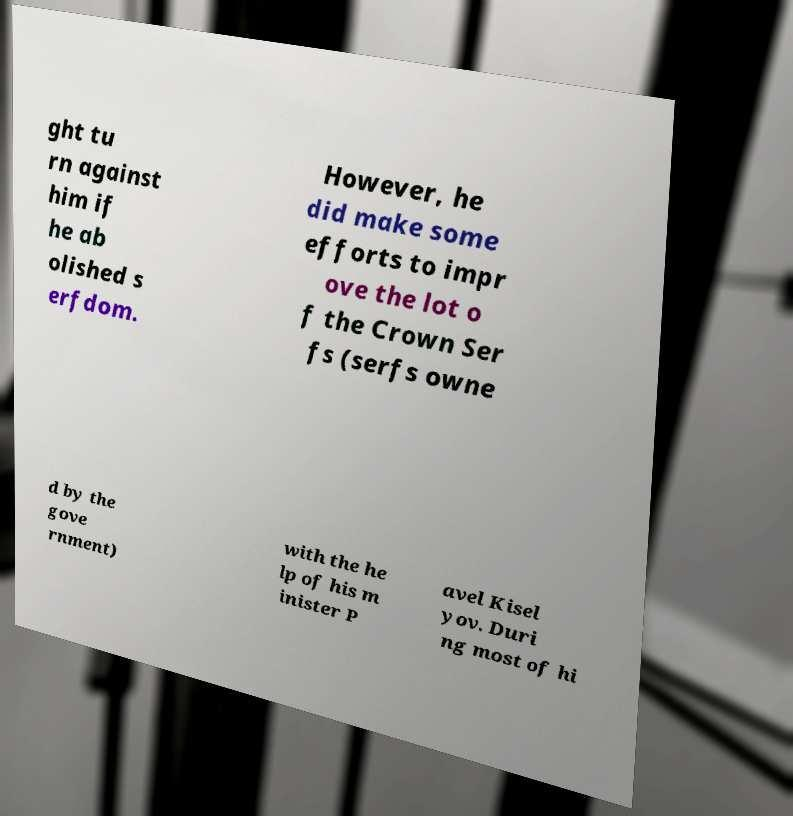Please read and relay the text visible in this image. What does it say? ght tu rn against him if he ab olished s erfdom. However, he did make some efforts to impr ove the lot o f the Crown Ser fs (serfs owne d by the gove rnment) with the he lp of his m inister P avel Kisel yov. Duri ng most of hi 